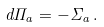Convert formula to latex. <formula><loc_0><loc_0><loc_500><loc_500>d \Pi _ { a } = - \Sigma _ { a } \, .</formula> 